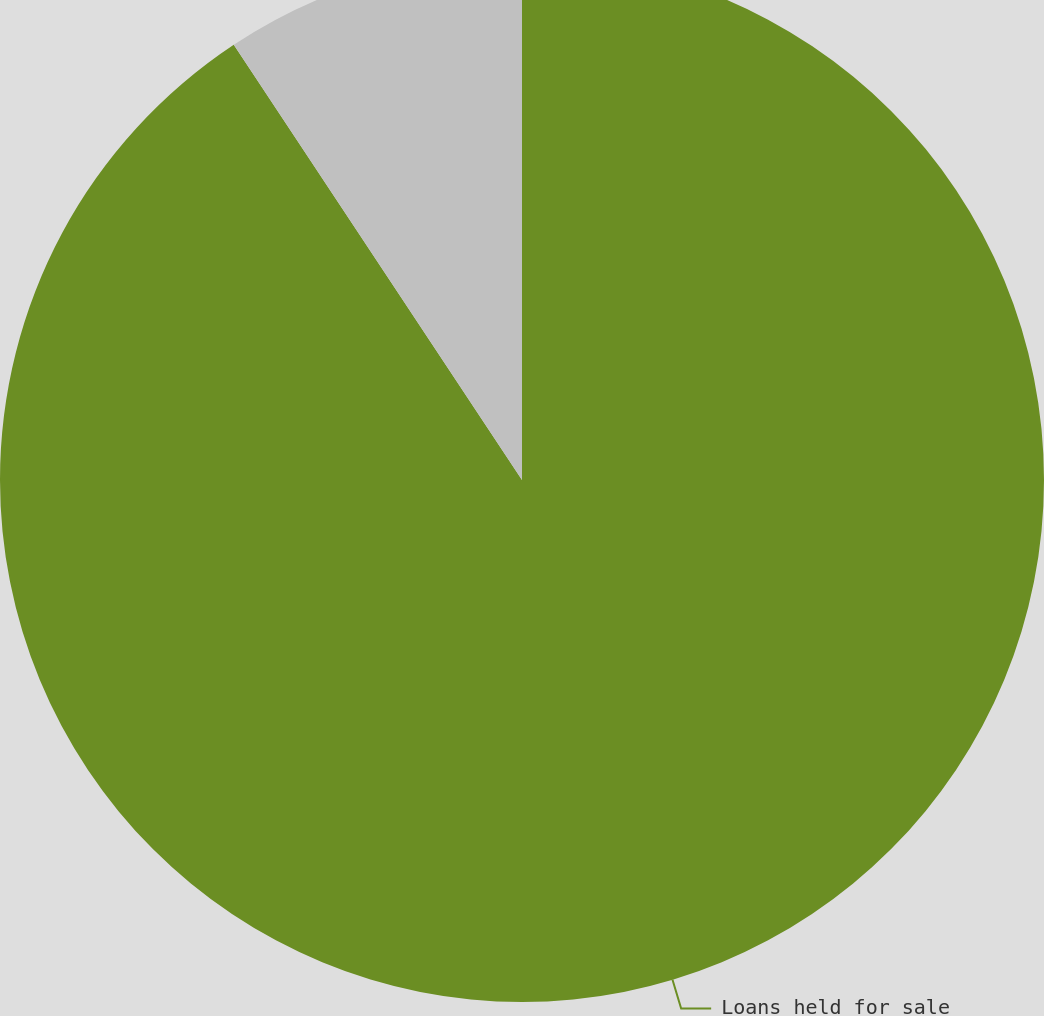Convert chart to OTSL. <chart><loc_0><loc_0><loc_500><loc_500><pie_chart><fcel>Loans held for sale<fcel>Loans held for investment<nl><fcel>90.69%<fcel>9.31%<nl></chart> 